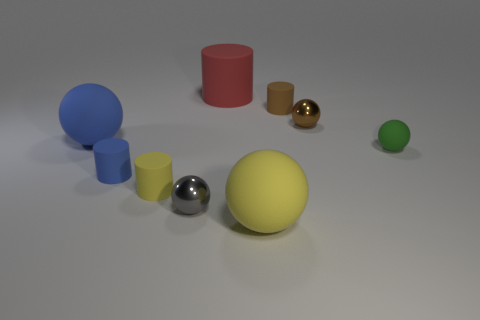Subtract all cylinders. How many objects are left? 5 Subtract 1 spheres. How many spheres are left? 4 Subtract all cyan cylinders. Subtract all cyan spheres. How many cylinders are left? 4 Subtract all red blocks. How many yellow cylinders are left? 1 Subtract all tiny matte cylinders. Subtract all small green balls. How many objects are left? 5 Add 8 green rubber objects. How many green rubber objects are left? 9 Add 4 big gray cylinders. How many big gray cylinders exist? 4 Subtract all green spheres. How many spheres are left? 4 Subtract all tiny metallic spheres. How many spheres are left? 3 Subtract 1 yellow cylinders. How many objects are left? 8 